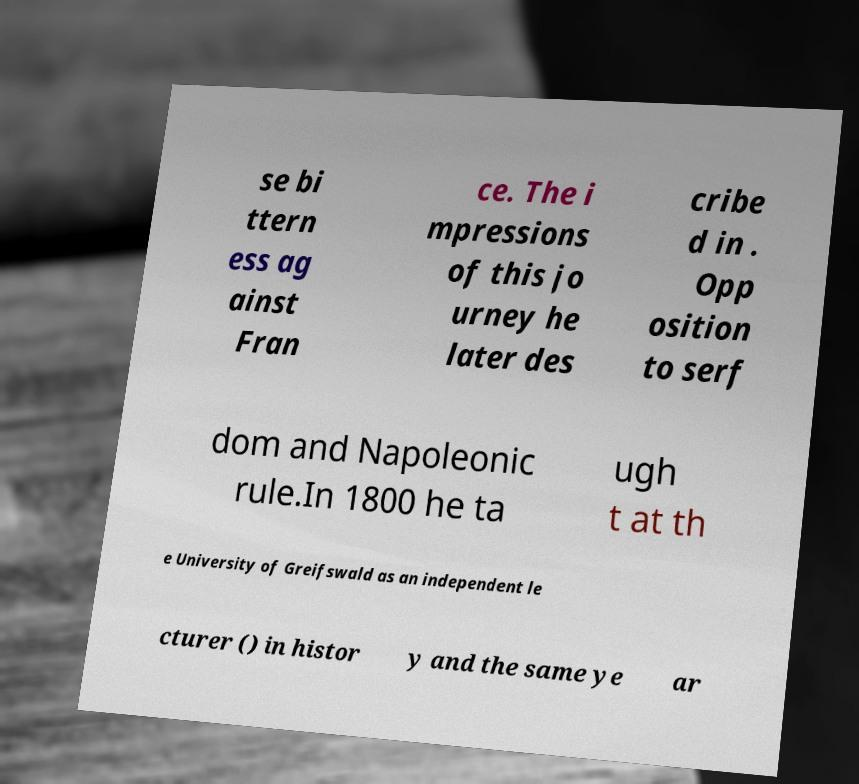Could you extract and type out the text from this image? se bi ttern ess ag ainst Fran ce. The i mpressions of this jo urney he later des cribe d in . Opp osition to serf dom and Napoleonic rule.In 1800 he ta ugh t at th e University of Greifswald as an independent le cturer () in histor y and the same ye ar 